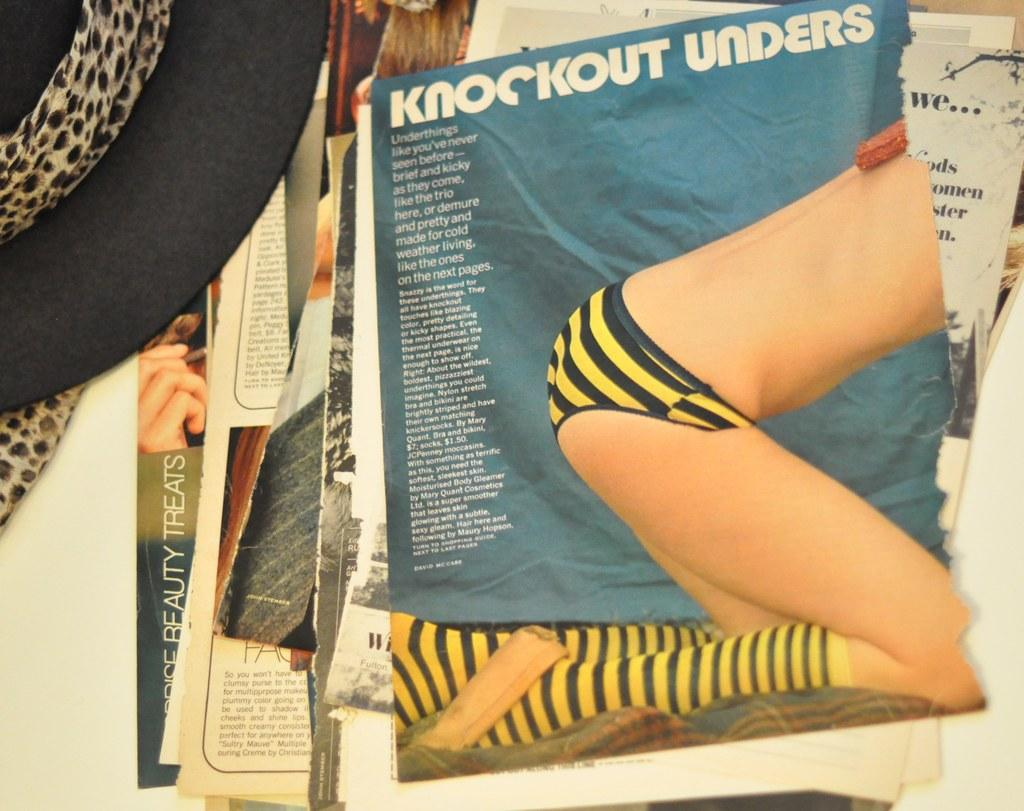<image>
Offer a succinct explanation of the picture presented. The magazine article has the title Knockout Unders. 